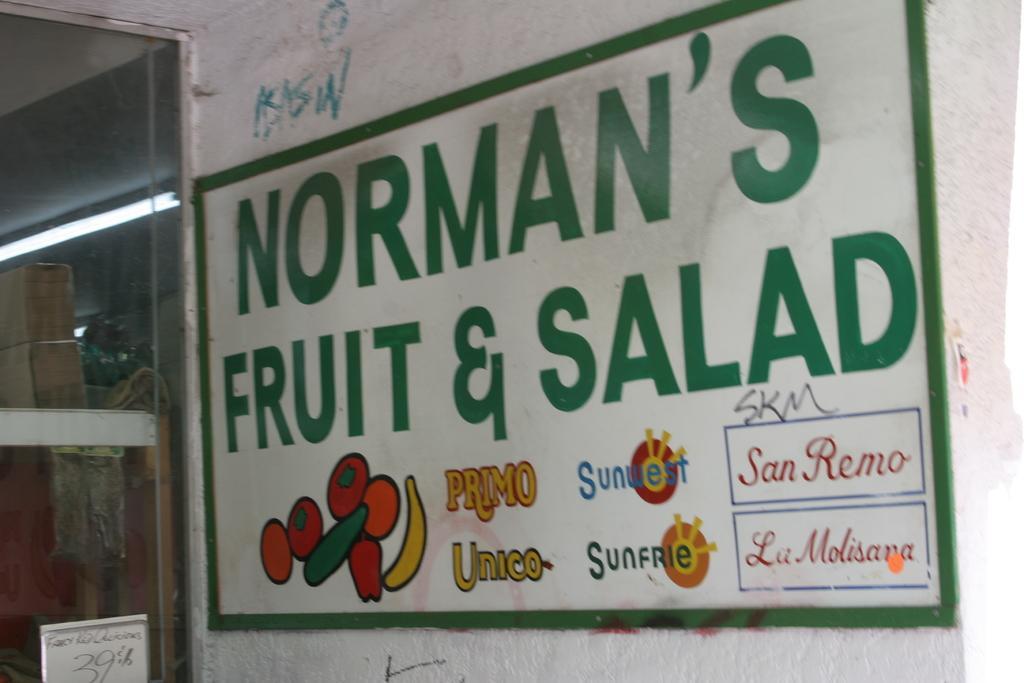In one or two sentences, can you explain what this image depicts? In this image I can see the board to the wall. I can see something is written on the board. To the left I can see the glass door and there is a light and some objects can be seen through the glass. 